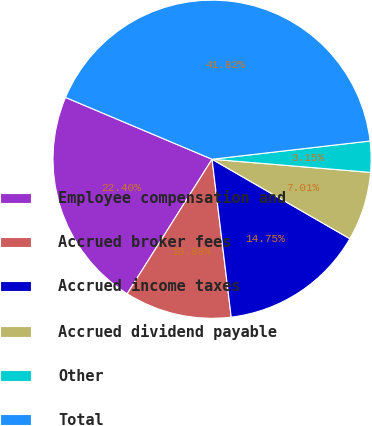Convert chart to OTSL. <chart><loc_0><loc_0><loc_500><loc_500><pie_chart><fcel>Employee compensation and<fcel>Accrued broker fees<fcel>Accrued income taxes<fcel>Accrued dividend payable<fcel>Other<fcel>Total<nl><fcel>22.4%<fcel>10.88%<fcel>14.75%<fcel>7.01%<fcel>3.15%<fcel>41.82%<nl></chart> 